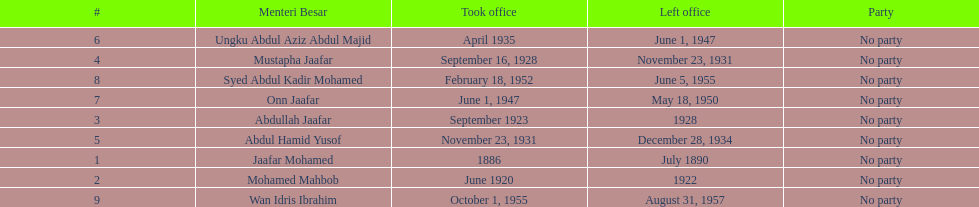What is the number of menteri besars that there have been during the pre-independence period? 9. 